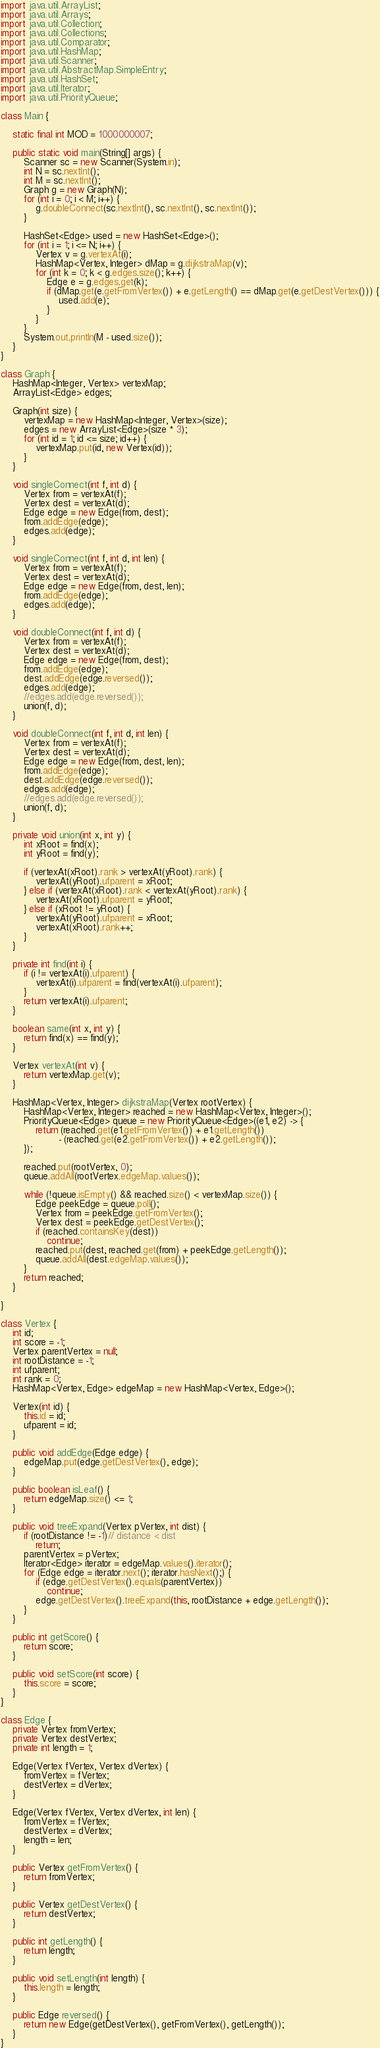Convert code to text. <code><loc_0><loc_0><loc_500><loc_500><_Java_>
import java.util.ArrayList;
import java.util.Arrays;
import java.util.Collection;
import java.util.Collections;
import java.util.Comparator;
import java.util.HashMap;
import java.util.Scanner;
import java.util.AbstractMap.SimpleEntry;
import java.util.HashSet;
import java.util.Iterator;
import java.util.PriorityQueue;

class Main {

    static final int MOD = 1000000007;

    public static void main(String[] args) {
        Scanner sc = new Scanner(System.in);
        int N = sc.nextInt();
        int M = sc.nextInt();
        Graph g = new Graph(N);
        for (int i = 0; i < M; i++) {
            g.doubleConnect(sc.nextInt(), sc.nextInt(), sc.nextInt());
        }

        HashSet<Edge> used = new HashSet<Edge>();
        for (int i = 1; i <= N; i++) {
            Vertex v = g.vertexAt(i);
            HashMap<Vertex, Integer> dMap = g.dijkstraMap(v);
            for (int k = 0; k < g.edges.size(); k++) {
                Edge e = g.edges.get(k);
                if (dMap.get(e.getFromVertex()) + e.getLength() == dMap.get(e.getDestVertex())) {
                    used.add(e);
                }
            }
        }
        System.out.println(M - used.size());
    }
}

class Graph {
    HashMap<Integer, Vertex> vertexMap;
    ArrayList<Edge> edges;

    Graph(int size) {
        vertexMap = new HashMap<Integer, Vertex>(size);
        edges = new ArrayList<Edge>(size * 3);
        for (int id = 1; id <= size; id++) {
            vertexMap.put(id, new Vertex(id));
        }
    }

    void singleConnect(int f, int d) {
        Vertex from = vertexAt(f);
        Vertex dest = vertexAt(d);
        Edge edge = new Edge(from, dest);
        from.addEdge(edge);
        edges.add(edge);
    }

    void singleConnect(int f, int d, int len) {
        Vertex from = vertexAt(f);
        Vertex dest = vertexAt(d);
        Edge edge = new Edge(from, dest, len);
        from.addEdge(edge);
        edges.add(edge);
    }

    void doubleConnect(int f, int d) {
        Vertex from = vertexAt(f);
        Vertex dest = vertexAt(d);
        Edge edge = new Edge(from, dest);
        from.addEdge(edge);
        dest.addEdge(edge.reversed());
        edges.add(edge);
        //edges.add(edge.reversed());
        union(f, d);
    }

    void doubleConnect(int f, int d, int len) {
        Vertex from = vertexAt(f);
        Vertex dest = vertexAt(d);
        Edge edge = new Edge(from, dest, len);
        from.addEdge(edge);
        dest.addEdge(edge.reversed());
        edges.add(edge);
        //edges.add(edge.reversed());
        union(f, d);
    }

    private void union(int x, int y) {
        int xRoot = find(x);
        int yRoot = find(y);

        if (vertexAt(xRoot).rank > vertexAt(yRoot).rank) {
            vertexAt(yRoot).ufparent = xRoot;
        } else if (vertexAt(xRoot).rank < vertexAt(yRoot).rank) {
            vertexAt(xRoot).ufparent = yRoot;
        } else if (xRoot != yRoot) {
            vertexAt(yRoot).ufparent = xRoot;
            vertexAt(xRoot).rank++;
        }
    }

    private int find(int i) {
        if (i != vertexAt(i).ufparent) {
            vertexAt(i).ufparent = find(vertexAt(i).ufparent);
        }
        return vertexAt(i).ufparent;
    }

    boolean same(int x, int y) {
        return find(x) == find(y);
    }

    Vertex vertexAt(int v) {
        return vertexMap.get(v);
    }

    HashMap<Vertex, Integer> dijkstraMap(Vertex rootVertex) {
        HashMap<Vertex, Integer> reached = new HashMap<Vertex, Integer>();
        PriorityQueue<Edge> queue = new PriorityQueue<Edge>((e1, e2) -> {
            return (reached.get(e1.getFromVertex()) + e1.getLength())
                    - (reached.get(e2.getFromVertex()) + e2.getLength());
        });

        reached.put(rootVertex, 0);
        queue.addAll(rootVertex.edgeMap.values());

        while (!queue.isEmpty() && reached.size() < vertexMap.size()) {
            Edge peekEdge = queue.poll();
            Vertex from = peekEdge.getFromVertex();
            Vertex dest = peekEdge.getDestVertex();
            if (reached.containsKey(dest))
                continue;
            reached.put(dest, reached.get(from) + peekEdge.getLength());
            queue.addAll(dest.edgeMap.values());
        }
        return reached;
    }

}

class Vertex {
    int id;
    int score = -1;
    Vertex parentVertex = null;
    int rootDistance = -1;
    int ufparent;
    int rank = 0;
    HashMap<Vertex, Edge> edgeMap = new HashMap<Vertex, Edge>();

    Vertex(int id) {
        this.id = id;
        ufparent = id;
    }

    public void addEdge(Edge edge) {
        edgeMap.put(edge.getDestVertex(), edge);
    }

    public boolean isLeaf() {
        return edgeMap.size() <= 1;
    }

    public void treeExpand(Vertex pVertex, int dist) {
        if (rootDistance != -1)// distance < dist
            return;
        parentVertex = pVertex;
        Iterator<Edge> iterator = edgeMap.values().iterator();
        for (Edge edge = iterator.next(); iterator.hasNext();) {
            if (edge.getDestVertex().equals(parentVertex))
                continue;
            edge.getDestVertex().treeExpand(this, rootDistance + edge.getLength());
        }
    }

    public int getScore() {
        return score;
    }

    public void setScore(int score) {
        this.score = score;
    }
}

class Edge {
    private Vertex fromVertex;
    private Vertex destVertex;
    private int length = 1;

    Edge(Vertex fVertex, Vertex dVertex) {
        fromVertex = fVertex;
        destVertex = dVertex;
    }

    Edge(Vertex fVertex, Vertex dVertex, int len) {
        fromVertex = fVertex;
        destVertex = dVertex;
        length = len;
    }

    public Vertex getFromVertex() {
        return fromVertex;
    }

    public Vertex getDestVertex() {
        return destVertex;
    }

    public int getLength() {
        return length;
    }

    public void setLength(int length) {
        this.length = length;
    }

    public Edge reversed() {
        return new Edge(getDestVertex(), getFromVertex(), getLength());
    }
}</code> 